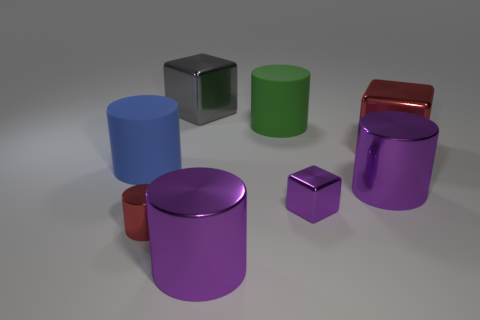What is the material of the large blue thing?
Your answer should be very brief. Rubber. What is the shape of the red shiny object to the left of the big gray block that is behind the large purple cylinder that is in front of the purple metal cube?
Make the answer very short. Cylinder. How many other objects are there of the same shape as the small red thing?
Offer a very short reply. 4. There is a tiny cylinder; is it the same color as the large cube that is on the left side of the small purple block?
Provide a succinct answer. No. How many purple rubber things are there?
Offer a terse response. 0. What number of things are large objects or tiny blocks?
Provide a short and direct response. 7. The thing that is the same color as the tiny cylinder is what size?
Provide a short and direct response. Large. There is a big gray object; are there any red metallic cubes in front of it?
Keep it short and to the point. Yes. Are there more large gray metallic objects that are on the left side of the large gray object than green matte objects that are right of the purple metal block?
Offer a very short reply. No. What is the size of the other matte object that is the same shape as the large blue matte thing?
Keep it short and to the point. Large. 